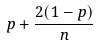Convert formula to latex. <formula><loc_0><loc_0><loc_500><loc_500>p + \frac { 2 ( 1 - p ) } { n }</formula> 